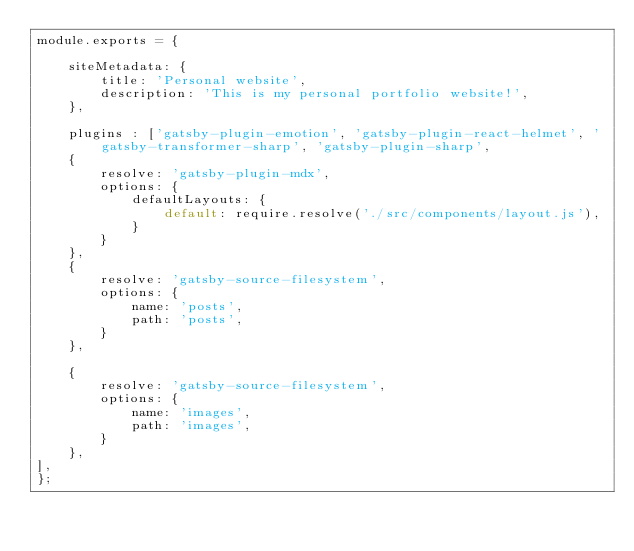Convert code to text. <code><loc_0><loc_0><loc_500><loc_500><_JavaScript_>module.exports = {

    siteMetadata: {
        title: 'Personal website',
        description: 'This is my personal portfolio website!',
    },

    plugins : ['gatsby-plugin-emotion', 'gatsby-plugin-react-helmet', 'gatsby-transformer-sharp', 'gatsby-plugin-sharp',
    {
        resolve: 'gatsby-plugin-mdx',
        options: {
            defaultLayouts: {
                default: require.resolve('./src/components/layout.js'),
            }
        }
    },
    {
        resolve: 'gatsby-source-filesystem',
        options: {
            name: 'posts',
            path: 'posts',
        }
    },
    
    {
        resolve: 'gatsby-source-filesystem',
        options: {
            name: 'images',
            path: 'images',
        }
    },
],
};</code> 